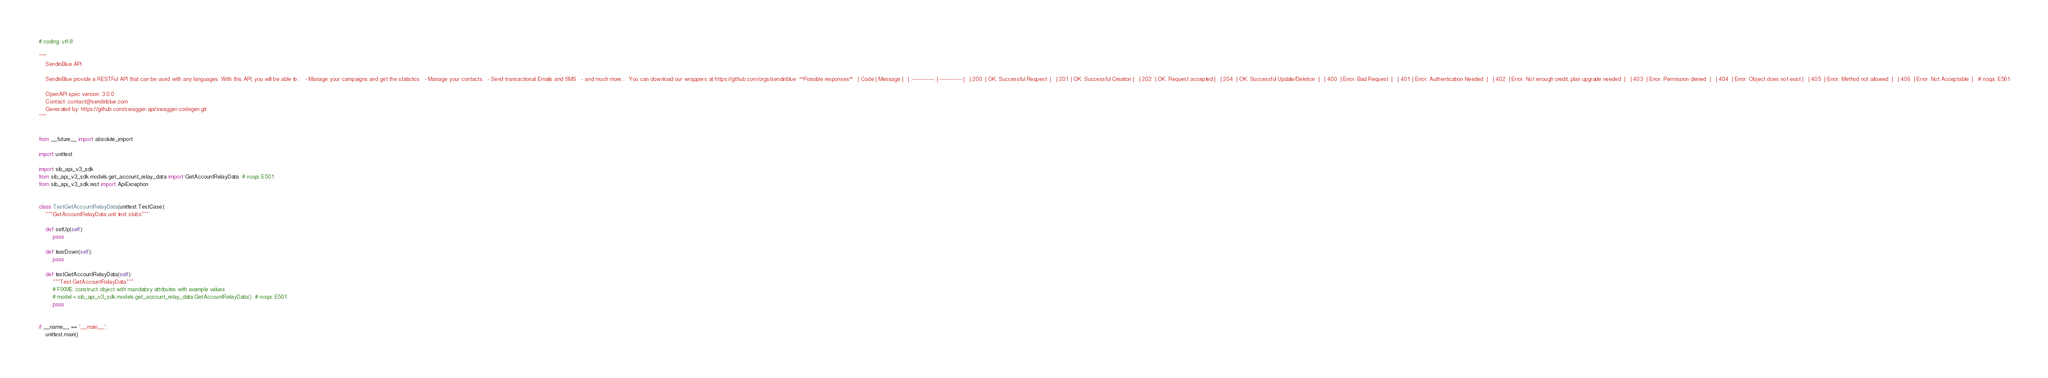<code> <loc_0><loc_0><loc_500><loc_500><_Python_># coding: utf-8

"""
    SendinBlue API

    SendinBlue provide a RESTFul API that can be used with any languages. With this API, you will be able to :   - Manage your campaigns and get the statistics   - Manage your contacts   - Send transactional Emails and SMS   - and much more...  You can download our wrappers at https://github.com/orgs/sendinblue  **Possible responses**   | Code | Message |   | :-------------: | ------------- |   | 200  | OK. Successful Request  |   | 201  | OK. Successful Creation |   | 202  | OK. Request accepted |   | 204  | OK. Successful Update/Deletion  |   | 400  | Error. Bad Request  |   | 401  | Error. Authentication Needed  |   | 402  | Error. Not enough credit, plan upgrade needed  |   | 403  | Error. Permission denied  |   | 404  | Error. Object does not exist |   | 405  | Error. Method not allowed  |   | 406  | Error. Not Acceptable  |   # noqa: E501

    OpenAPI spec version: 3.0.0
    Contact: contact@sendinblue.com
    Generated by: https://github.com/swagger-api/swagger-codegen.git
"""


from __future__ import absolute_import

import unittest

import sib_api_v3_sdk
from sib_api_v3_sdk.models.get_account_relay_data import GetAccountRelayData  # noqa: E501
from sib_api_v3_sdk.rest import ApiException


class TestGetAccountRelayData(unittest.TestCase):
    """GetAccountRelayData unit test stubs"""

    def setUp(self):
        pass

    def tearDown(self):
        pass

    def testGetAccountRelayData(self):
        """Test GetAccountRelayData"""
        # FIXME: construct object with mandatory attributes with example values
        # model = sib_api_v3_sdk.models.get_account_relay_data.GetAccountRelayData()  # noqa: E501
        pass


if __name__ == '__main__':
    unittest.main()
</code> 